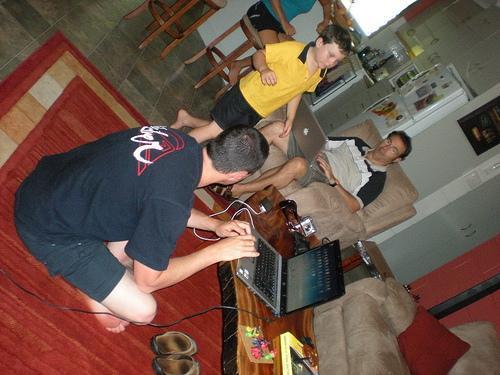How many people are in photo?
Give a very brief answer. 4. 